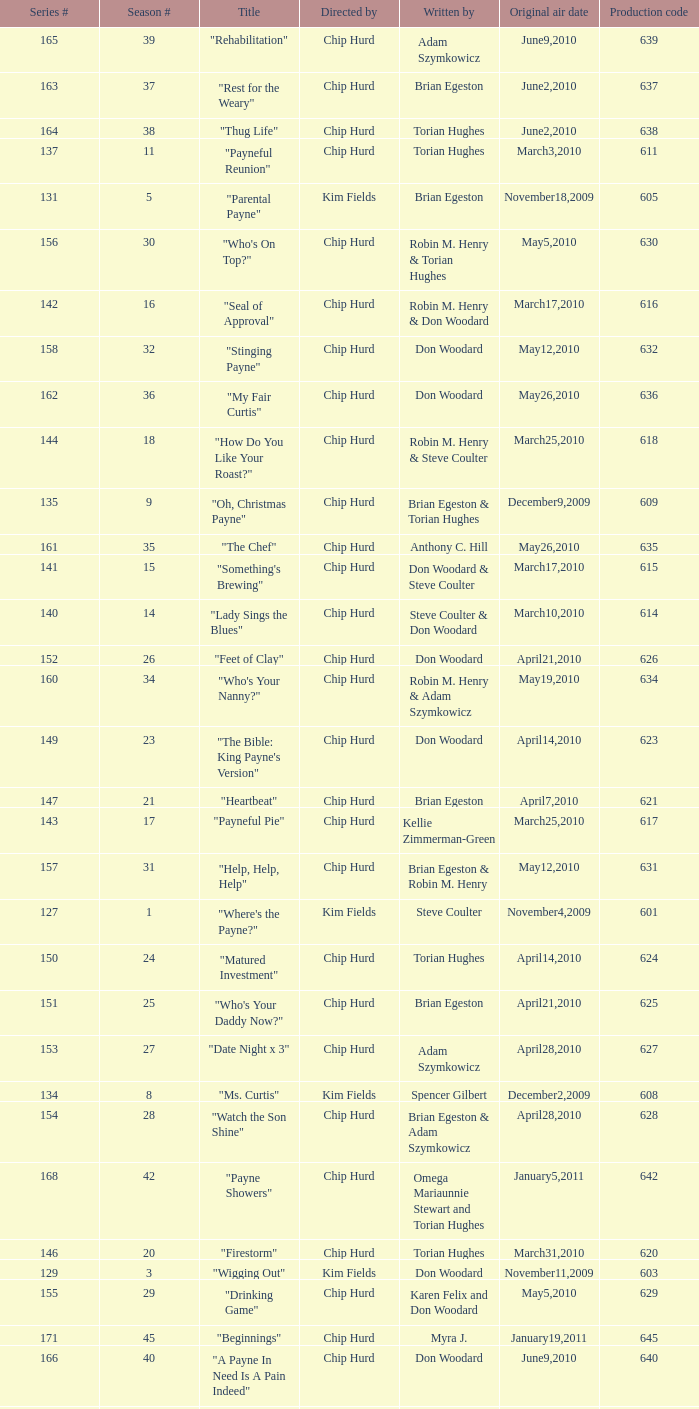What is the title of the episode with the production code 624? "Matured Investment". 